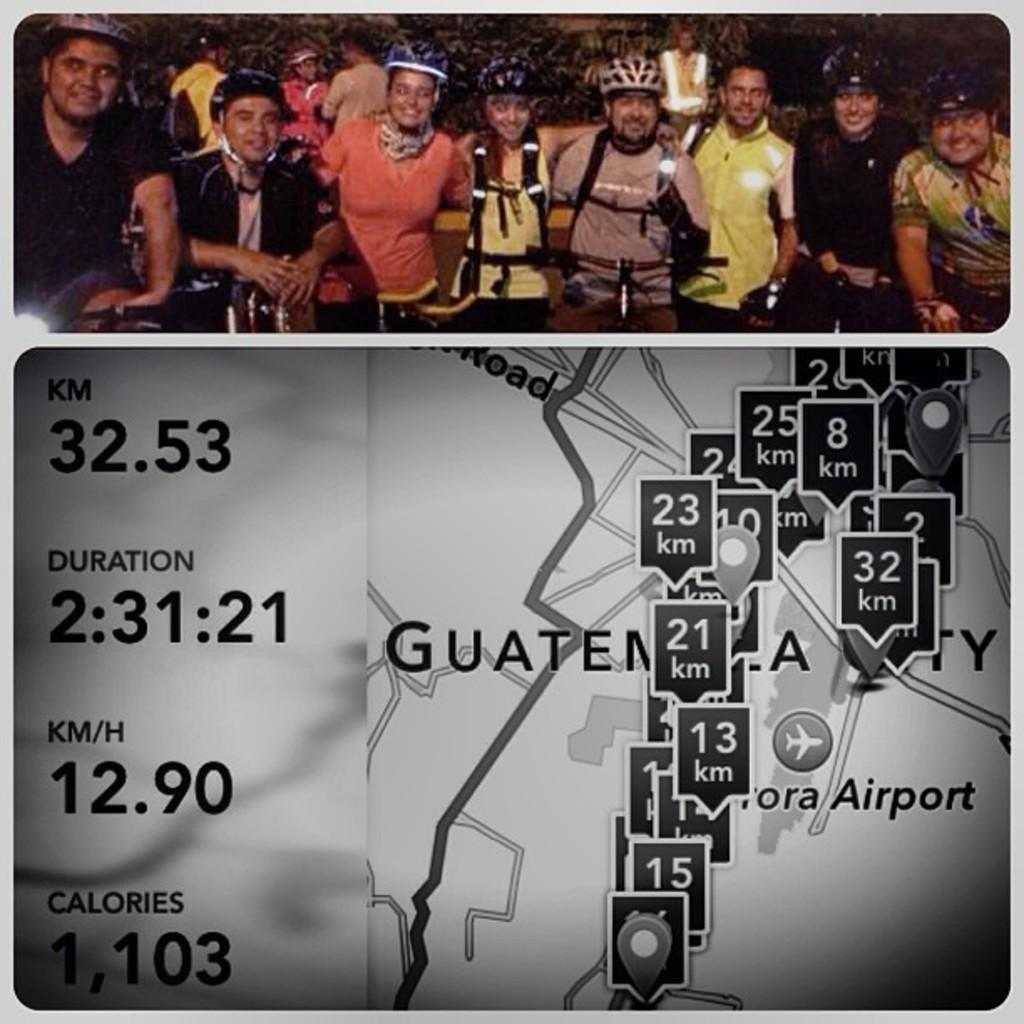How many images are present in the picture? There are two images in the picture. What can be seen in the top image? At the top of the image, there are persons, bicycles, plants, and objects. What elements are present in the bottom image? At the bottom of the image, there is a map, numbers, and texts. What type of muscle can be seen being used by the person in the image? There is no person or muscle visible in the image; it contains two images with various objects and elements. 